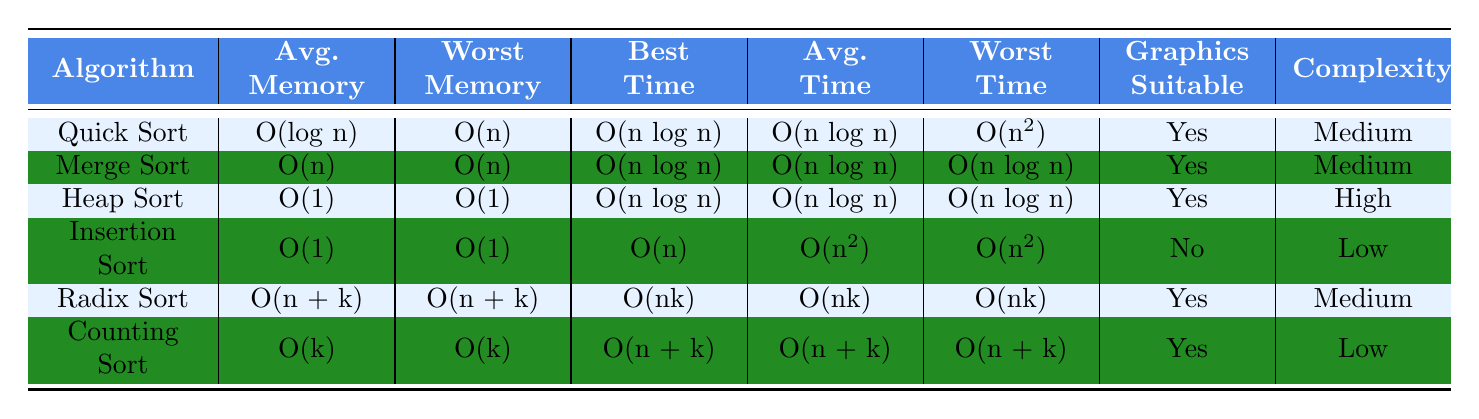What is the worst-case memory usage of Quick Sort? According to the table, the worst-case memory usage of Quick Sort is listed as O(n).
Answer: O(n) Which sorting algorithm has the best-case execution time of O(n)? Looking at the table, the only sorting algorithm with a best-case execution time of O(n) is Insertion Sort.
Answer: Insertion Sort How many sorting algorithms are suitable for graphics applications? The table shows that Quick Sort, Merge Sort, Heap Sort, Radix Sort, and Counting Sort are all suitable for graphics applications, totaling five algorithms.
Answer: Five What is the average execution time for Heap Sort compared to Merge Sort? The average execution time for Heap Sort is O(n log n), and for Merge Sort, it is also O(n log n). Since both are equal, they have the same average execution time.
Answer: They are equal Which sorting algorithm has the highest implementation complexity? In the table, Heap Sort is noted to have a high complexity, which is higher than the others listed.
Answer: Heap Sort What is the relationship between the worst-case execution time and average case execution time for Merge Sort? For Merge Sort, both the worst-case and average-case execution times are O(n log n), indicating they are the same in this case.
Answer: They are the same If you were to choose a sorting algorithm with low implementation complexity that is suitable for graphics applications, which would you choose? From the table, both Counting Sort and Insertion Sort have low implementation complexity, but only Counting Sort is suitable for graphics applications.
Answer: Counting Sort Which algorithm has the best worst-case execution time, and what is its time? Analyzing the table, all sorting algorithms except Insertion Sort have a worst-case execution time of O(n log n), which is superior compared to Insertion Sort's O(n^2). Merge Sort, Heap Sort, and Quick Sort are tied for best with O(n log n).
Answer: O(n log n) What is the average memory usage of Radix Sort, and how does it compare to Counting Sort? Radix Sort's average memory usage is O(n + k), while Counting Sort's average usage is O(k). Radix Sort uses potentially more memory than Counting Sort, especially as n increases.
Answer: O(n + k) is more than O(k) 